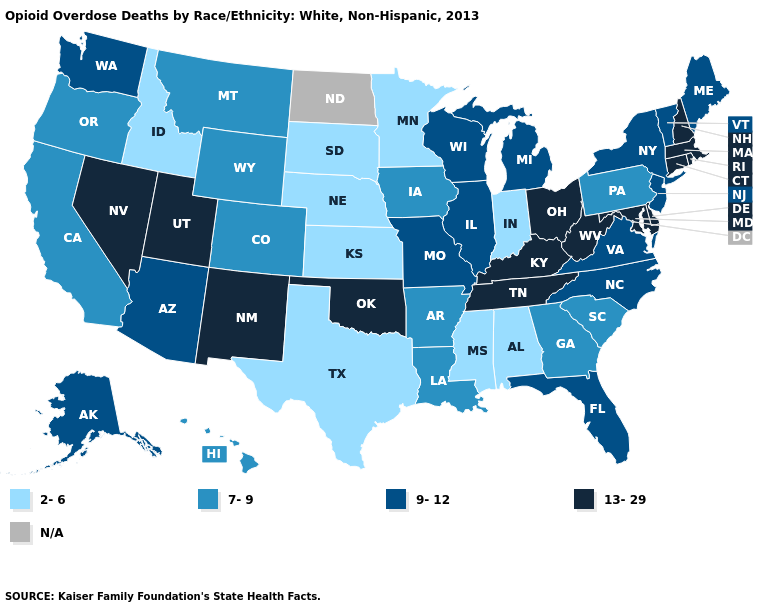Is the legend a continuous bar?
Give a very brief answer. No. What is the value of New Mexico?
Quick response, please. 13-29. Which states have the lowest value in the MidWest?
Keep it brief. Indiana, Kansas, Minnesota, Nebraska, South Dakota. Among the states that border Vermont , which have the highest value?
Keep it brief. Massachusetts, New Hampshire. What is the lowest value in states that border Oregon?
Concise answer only. 2-6. Does New Mexico have the highest value in the West?
Be succinct. Yes. Name the states that have a value in the range 9-12?
Answer briefly. Alaska, Arizona, Florida, Illinois, Maine, Michigan, Missouri, New Jersey, New York, North Carolina, Vermont, Virginia, Washington, Wisconsin. What is the value of Maine?
Short answer required. 9-12. Among the states that border Kansas , does Oklahoma have the highest value?
Concise answer only. Yes. What is the value of Mississippi?
Keep it brief. 2-6. Name the states that have a value in the range 7-9?
Write a very short answer. Arkansas, California, Colorado, Georgia, Hawaii, Iowa, Louisiana, Montana, Oregon, Pennsylvania, South Carolina, Wyoming. Which states have the lowest value in the USA?
Answer briefly. Alabama, Idaho, Indiana, Kansas, Minnesota, Mississippi, Nebraska, South Dakota, Texas. Does the first symbol in the legend represent the smallest category?
Be succinct. Yes. What is the value of Minnesota?
Give a very brief answer. 2-6. What is the value of Massachusetts?
Answer briefly. 13-29. 